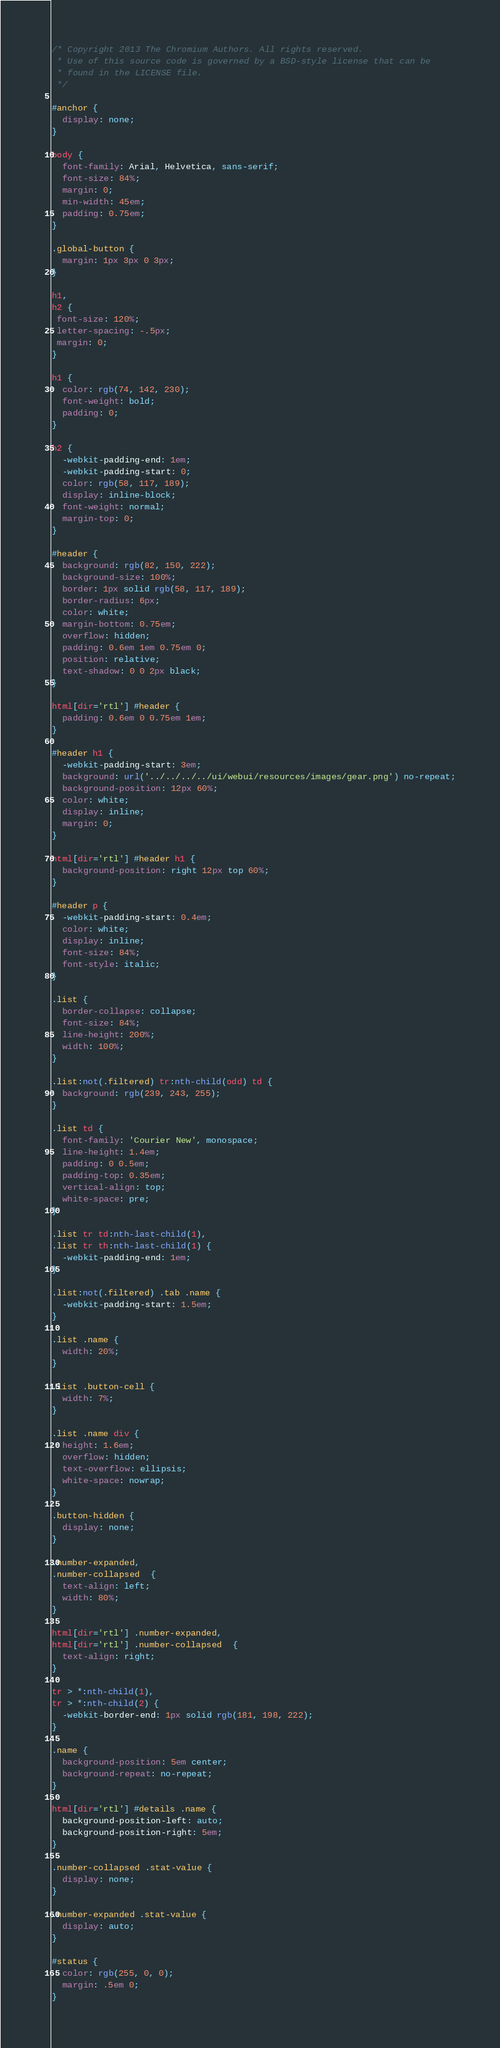Convert code to text. <code><loc_0><loc_0><loc_500><loc_500><_CSS_>/* Copyright 2013 The Chromium Authors. All rights reserved.
 * Use of this source code is governed by a BSD-style license that can be
 * found in the LICENSE file.
 */

#anchor {
  display: none;
}

body {
  font-family: Arial, Helvetica, sans-serif;
  font-size: 84%;
  margin: 0;
  min-width: 45em;
  padding: 0.75em;
}

.global-button {
  margin: 1px 3px 0 3px;
}

h1,
h2 {
 font-size: 120%;
 letter-spacing: -.5px;
 margin: 0;
}

h1 {
  color: rgb(74, 142, 230);
  font-weight: bold;
  padding: 0;
}

h2 {
  -webkit-padding-end: 1em;
  -webkit-padding-start: 0;
  color: rgb(58, 117, 189);
  display: inline-block;
  font-weight: normal;
  margin-top: 0;
}

#header {
  background: rgb(82, 150, 222);
  background-size: 100%;
  border: 1px solid rgb(58, 117, 189);
  border-radius: 6px;
  color: white;
  margin-bottom: 0.75em;
  overflow: hidden;
  padding: 0.6em 1em 0.75em 0;
  position: relative;
  text-shadow: 0 0 2px black;
}

html[dir='rtl'] #header {
  padding: 0.6em 0 0.75em 1em;
}

#header h1 {
  -webkit-padding-start: 3em;
  background: url('../../../../ui/webui/resources/images/gear.png') no-repeat;
  background-position: 12px 60%;
  color: white;
  display: inline;
  margin: 0;
}

html[dir='rtl'] #header h1 {
  background-position: right 12px top 60%;
}

#header p {
  -webkit-padding-start: 0.4em;
  color: white;
  display: inline;
  font-size: 84%;
  font-style: italic;
}

.list {
  border-collapse: collapse;
  font-size: 84%;
  line-height: 200%;
  width: 100%;
}

.list:not(.filtered) tr:nth-child(odd) td {
  background: rgb(239, 243, 255);
}

.list td {
  font-family: 'Courier New', monospace;
  line-height: 1.4em;
  padding: 0 0.5em;
  padding-top: 0.35em;
  vertical-align: top;
  white-space: pre;
}

.list tr td:nth-last-child(1),
.list tr th:nth-last-child(1) {
  -webkit-padding-end: 1em;
}

.list:not(.filtered) .tab .name {
  -webkit-padding-start: 1.5em;
}

.list .name {
  width: 20%;
}

.list .button-cell {
  width: 7%;
}

.list .name div {
  height: 1.6em;
  overflow: hidden;
  text-overflow: ellipsis;
  white-space: nowrap;
}

.button-hidden {
  display: none;
}

.number-expanded,
.number-collapsed  {
  text-align: left;
  width: 80%;
}

html[dir='rtl'] .number-expanded,
html[dir='rtl'] .number-collapsed  {
  text-align: right;
}

tr > *:nth-child(1),
tr > *:nth-child(2) {
  -webkit-border-end: 1px solid rgb(181, 198, 222);
}

.name {
  background-position: 5em center;
  background-repeat: no-repeat;
}

html[dir='rtl'] #details .name {
  background-position-left: auto;
  background-position-right: 5em;
}

.number-collapsed .stat-value {
  display: none;
}

.number-expanded .stat-value {
  display: auto;
}

#status {
  color: rgb(255, 0, 0);
  margin: .5em 0;
}
</code> 